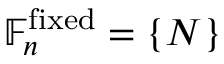<formula> <loc_0><loc_0><loc_500><loc_500>\mathbb { F } _ { n } ^ { f i x e d } = \{ N \}</formula> 